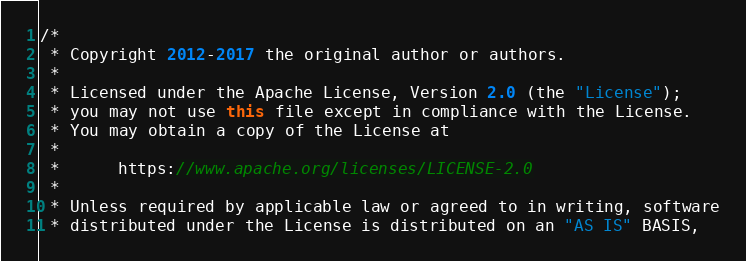<code> <loc_0><loc_0><loc_500><loc_500><_Java_>/*
 * Copyright 2012-2017 the original author or authors.
 *
 * Licensed under the Apache License, Version 2.0 (the "License");
 * you may not use this file except in compliance with the License.
 * You may obtain a copy of the License at
 *
 *      https://www.apache.org/licenses/LICENSE-2.0
 *
 * Unless required by applicable law or agreed to in writing, software
 * distributed under the License is distributed on an "AS IS" BASIS,</code> 